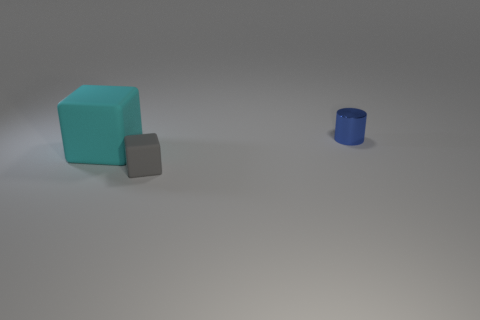There is a cyan cube; is its size the same as the thing behind the cyan cube?
Your answer should be very brief. No. What number of cyan cubes are the same size as the cyan matte thing?
Keep it short and to the point. 0. There is a tiny block that is the same material as the big cube; what is its color?
Keep it short and to the point. Gray. Are there more cyan matte balls than small gray things?
Your answer should be compact. No. Is the material of the cyan object the same as the blue cylinder?
Give a very brief answer. No. There is a thing that is the same material as the small gray block; what shape is it?
Keep it short and to the point. Cube. Are there fewer tiny blue shiny cubes than large matte things?
Make the answer very short. Yes. There is a thing that is both to the right of the large cyan matte object and left of the tiny blue metal object; what is its material?
Keep it short and to the point. Rubber. How big is the matte thing behind the small object in front of the matte thing to the left of the tiny gray matte block?
Make the answer very short. Large. There is a big cyan rubber object; is its shape the same as the tiny object that is left of the tiny metal object?
Give a very brief answer. Yes. 